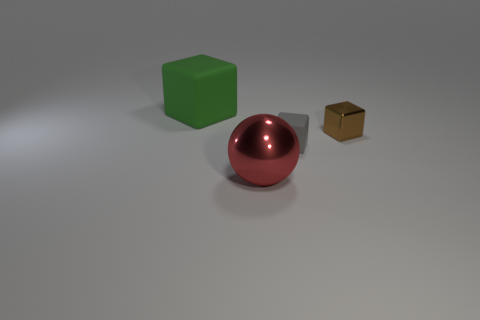Add 4 gray rubber things. How many objects exist? 8 Subtract all balls. How many objects are left? 3 Subtract all big shiny things. Subtract all blue shiny things. How many objects are left? 3 Add 2 large matte cubes. How many large matte cubes are left? 3 Add 2 small brown rubber objects. How many small brown rubber objects exist? 2 Subtract 0 gray balls. How many objects are left? 4 